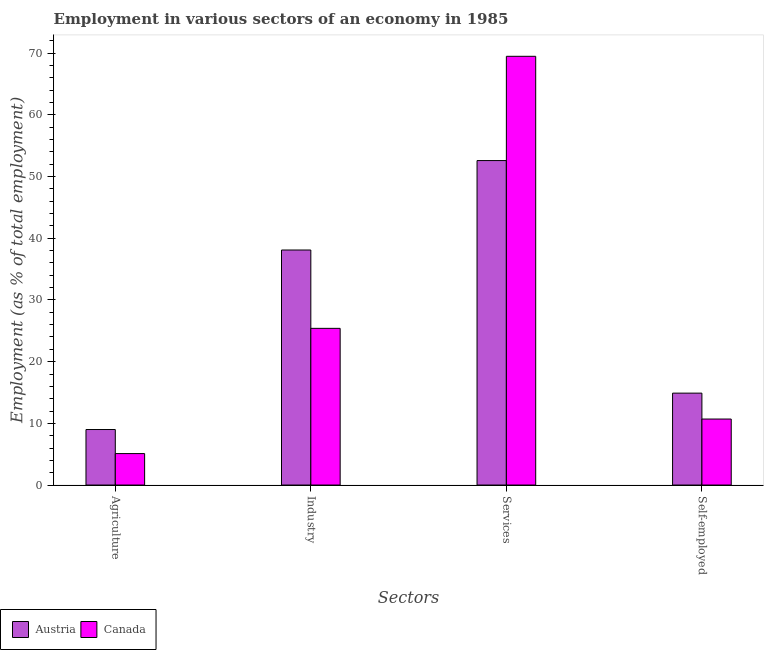How many different coloured bars are there?
Provide a short and direct response. 2. How many groups of bars are there?
Offer a very short reply. 4. How many bars are there on the 1st tick from the left?
Give a very brief answer. 2. What is the label of the 3rd group of bars from the left?
Provide a short and direct response. Services. What is the percentage of workers in industry in Austria?
Provide a short and direct response. 38.1. Across all countries, what is the maximum percentage of workers in services?
Make the answer very short. 69.5. Across all countries, what is the minimum percentage of workers in services?
Your answer should be very brief. 52.6. In which country was the percentage of self employed workers maximum?
Provide a succinct answer. Austria. In which country was the percentage of workers in industry minimum?
Keep it short and to the point. Canada. What is the total percentage of workers in agriculture in the graph?
Give a very brief answer. 14.1. What is the difference between the percentage of self employed workers in Canada and that in Austria?
Provide a short and direct response. -4.2. What is the difference between the percentage of self employed workers in Canada and the percentage of workers in services in Austria?
Your answer should be very brief. -41.9. What is the average percentage of workers in agriculture per country?
Provide a short and direct response. 7.05. What is the difference between the percentage of workers in industry and percentage of workers in agriculture in Canada?
Provide a succinct answer. 20.3. In how many countries, is the percentage of self employed workers greater than 10 %?
Provide a succinct answer. 2. What is the ratio of the percentage of workers in industry in Austria to that in Canada?
Give a very brief answer. 1.5. Is the percentage of workers in services in Austria less than that in Canada?
Offer a very short reply. Yes. Is the difference between the percentage of self employed workers in Austria and Canada greater than the difference between the percentage of workers in agriculture in Austria and Canada?
Keep it short and to the point. Yes. What is the difference between the highest and the second highest percentage of workers in industry?
Your answer should be compact. 12.7. What is the difference between the highest and the lowest percentage of self employed workers?
Provide a succinct answer. 4.2. In how many countries, is the percentage of self employed workers greater than the average percentage of self employed workers taken over all countries?
Provide a succinct answer. 1. Is the sum of the percentage of workers in services in Canada and Austria greater than the maximum percentage of workers in industry across all countries?
Give a very brief answer. Yes. Is it the case that in every country, the sum of the percentage of workers in services and percentage of self employed workers is greater than the sum of percentage of workers in industry and percentage of workers in agriculture?
Make the answer very short. Yes. What does the 1st bar from the left in Industry represents?
Your answer should be compact. Austria. What does the 1st bar from the right in Services represents?
Offer a very short reply. Canada. Are all the bars in the graph horizontal?
Keep it short and to the point. No. Does the graph contain any zero values?
Your answer should be very brief. No. Does the graph contain grids?
Provide a succinct answer. No. Where does the legend appear in the graph?
Your answer should be compact. Bottom left. What is the title of the graph?
Provide a succinct answer. Employment in various sectors of an economy in 1985. Does "Brazil" appear as one of the legend labels in the graph?
Provide a succinct answer. No. What is the label or title of the X-axis?
Make the answer very short. Sectors. What is the label or title of the Y-axis?
Provide a short and direct response. Employment (as % of total employment). What is the Employment (as % of total employment) in Canada in Agriculture?
Give a very brief answer. 5.1. What is the Employment (as % of total employment) of Austria in Industry?
Provide a short and direct response. 38.1. What is the Employment (as % of total employment) of Canada in Industry?
Offer a very short reply. 25.4. What is the Employment (as % of total employment) of Austria in Services?
Ensure brevity in your answer.  52.6. What is the Employment (as % of total employment) of Canada in Services?
Provide a succinct answer. 69.5. What is the Employment (as % of total employment) of Austria in Self-employed?
Provide a short and direct response. 14.9. What is the Employment (as % of total employment) of Canada in Self-employed?
Offer a terse response. 10.7. Across all Sectors, what is the maximum Employment (as % of total employment) in Austria?
Provide a succinct answer. 52.6. Across all Sectors, what is the maximum Employment (as % of total employment) of Canada?
Provide a short and direct response. 69.5. Across all Sectors, what is the minimum Employment (as % of total employment) of Austria?
Provide a succinct answer. 9. Across all Sectors, what is the minimum Employment (as % of total employment) of Canada?
Your response must be concise. 5.1. What is the total Employment (as % of total employment) of Austria in the graph?
Give a very brief answer. 114.6. What is the total Employment (as % of total employment) in Canada in the graph?
Your answer should be very brief. 110.7. What is the difference between the Employment (as % of total employment) in Austria in Agriculture and that in Industry?
Keep it short and to the point. -29.1. What is the difference between the Employment (as % of total employment) of Canada in Agriculture and that in Industry?
Offer a very short reply. -20.3. What is the difference between the Employment (as % of total employment) of Austria in Agriculture and that in Services?
Offer a terse response. -43.6. What is the difference between the Employment (as % of total employment) in Canada in Agriculture and that in Services?
Your answer should be compact. -64.4. What is the difference between the Employment (as % of total employment) in Austria in Industry and that in Services?
Offer a terse response. -14.5. What is the difference between the Employment (as % of total employment) of Canada in Industry and that in Services?
Provide a succinct answer. -44.1. What is the difference between the Employment (as % of total employment) of Austria in Industry and that in Self-employed?
Your answer should be very brief. 23.2. What is the difference between the Employment (as % of total employment) in Austria in Services and that in Self-employed?
Offer a terse response. 37.7. What is the difference between the Employment (as % of total employment) in Canada in Services and that in Self-employed?
Your answer should be compact. 58.8. What is the difference between the Employment (as % of total employment) in Austria in Agriculture and the Employment (as % of total employment) in Canada in Industry?
Provide a short and direct response. -16.4. What is the difference between the Employment (as % of total employment) in Austria in Agriculture and the Employment (as % of total employment) in Canada in Services?
Provide a succinct answer. -60.5. What is the difference between the Employment (as % of total employment) of Austria in Agriculture and the Employment (as % of total employment) of Canada in Self-employed?
Keep it short and to the point. -1.7. What is the difference between the Employment (as % of total employment) in Austria in Industry and the Employment (as % of total employment) in Canada in Services?
Your answer should be very brief. -31.4. What is the difference between the Employment (as % of total employment) in Austria in Industry and the Employment (as % of total employment) in Canada in Self-employed?
Provide a succinct answer. 27.4. What is the difference between the Employment (as % of total employment) in Austria in Services and the Employment (as % of total employment) in Canada in Self-employed?
Offer a very short reply. 41.9. What is the average Employment (as % of total employment) in Austria per Sectors?
Provide a short and direct response. 28.65. What is the average Employment (as % of total employment) in Canada per Sectors?
Keep it short and to the point. 27.68. What is the difference between the Employment (as % of total employment) in Austria and Employment (as % of total employment) in Canada in Agriculture?
Your answer should be very brief. 3.9. What is the difference between the Employment (as % of total employment) of Austria and Employment (as % of total employment) of Canada in Industry?
Provide a succinct answer. 12.7. What is the difference between the Employment (as % of total employment) in Austria and Employment (as % of total employment) in Canada in Services?
Make the answer very short. -16.9. What is the difference between the Employment (as % of total employment) of Austria and Employment (as % of total employment) of Canada in Self-employed?
Provide a succinct answer. 4.2. What is the ratio of the Employment (as % of total employment) in Austria in Agriculture to that in Industry?
Make the answer very short. 0.24. What is the ratio of the Employment (as % of total employment) of Canada in Agriculture to that in Industry?
Ensure brevity in your answer.  0.2. What is the ratio of the Employment (as % of total employment) of Austria in Agriculture to that in Services?
Ensure brevity in your answer.  0.17. What is the ratio of the Employment (as % of total employment) in Canada in Agriculture to that in Services?
Your answer should be compact. 0.07. What is the ratio of the Employment (as % of total employment) of Austria in Agriculture to that in Self-employed?
Give a very brief answer. 0.6. What is the ratio of the Employment (as % of total employment) of Canada in Agriculture to that in Self-employed?
Provide a short and direct response. 0.48. What is the ratio of the Employment (as % of total employment) in Austria in Industry to that in Services?
Keep it short and to the point. 0.72. What is the ratio of the Employment (as % of total employment) of Canada in Industry to that in Services?
Ensure brevity in your answer.  0.37. What is the ratio of the Employment (as % of total employment) of Austria in Industry to that in Self-employed?
Offer a terse response. 2.56. What is the ratio of the Employment (as % of total employment) of Canada in Industry to that in Self-employed?
Your response must be concise. 2.37. What is the ratio of the Employment (as % of total employment) in Austria in Services to that in Self-employed?
Make the answer very short. 3.53. What is the ratio of the Employment (as % of total employment) of Canada in Services to that in Self-employed?
Give a very brief answer. 6.5. What is the difference between the highest and the second highest Employment (as % of total employment) in Austria?
Offer a very short reply. 14.5. What is the difference between the highest and the second highest Employment (as % of total employment) in Canada?
Keep it short and to the point. 44.1. What is the difference between the highest and the lowest Employment (as % of total employment) in Austria?
Offer a terse response. 43.6. What is the difference between the highest and the lowest Employment (as % of total employment) of Canada?
Provide a short and direct response. 64.4. 